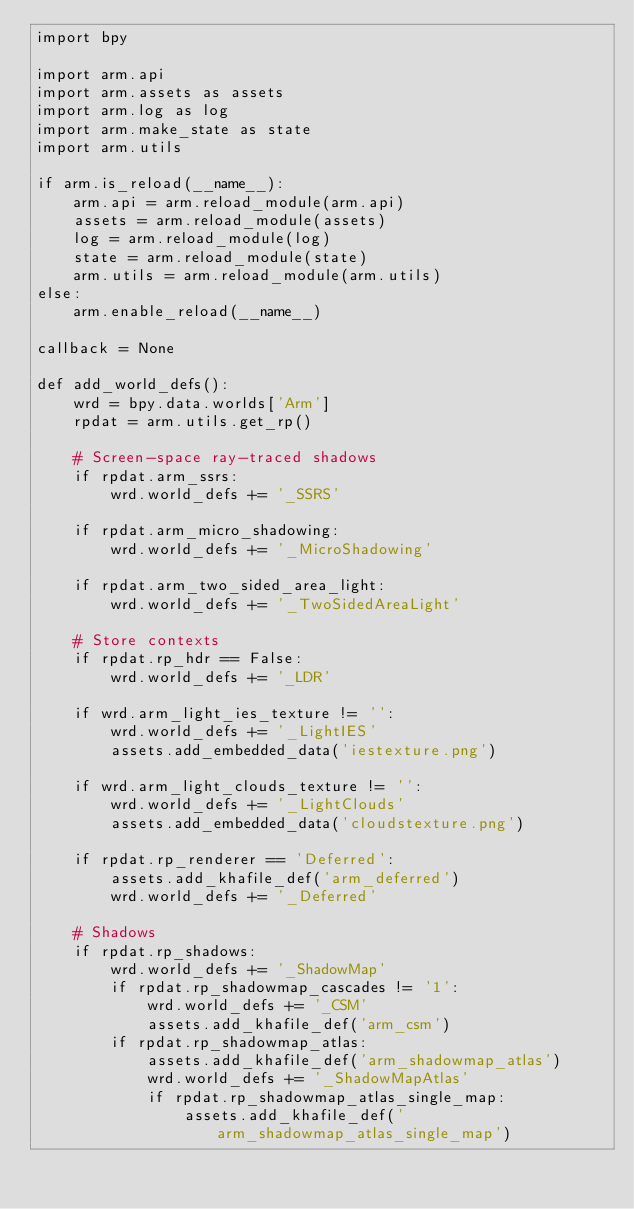<code> <loc_0><loc_0><loc_500><loc_500><_Python_>import bpy

import arm.api
import arm.assets as assets
import arm.log as log
import arm.make_state as state
import arm.utils

if arm.is_reload(__name__):
    arm.api = arm.reload_module(arm.api)
    assets = arm.reload_module(assets)
    log = arm.reload_module(log)
    state = arm.reload_module(state)
    arm.utils = arm.reload_module(arm.utils)
else:
    arm.enable_reload(__name__)

callback = None

def add_world_defs():
    wrd = bpy.data.worlds['Arm']
    rpdat = arm.utils.get_rp()

    # Screen-space ray-traced shadows
    if rpdat.arm_ssrs:
        wrd.world_defs += '_SSRS'

    if rpdat.arm_micro_shadowing:
        wrd.world_defs += '_MicroShadowing'

    if rpdat.arm_two_sided_area_light:
        wrd.world_defs += '_TwoSidedAreaLight'

    # Store contexts
    if rpdat.rp_hdr == False:
        wrd.world_defs += '_LDR'

    if wrd.arm_light_ies_texture != '':
        wrd.world_defs += '_LightIES'
        assets.add_embedded_data('iestexture.png')

    if wrd.arm_light_clouds_texture != '':
        wrd.world_defs += '_LightClouds'
        assets.add_embedded_data('cloudstexture.png')

    if rpdat.rp_renderer == 'Deferred':
        assets.add_khafile_def('arm_deferred')
        wrd.world_defs += '_Deferred'

    # Shadows
    if rpdat.rp_shadows:
        wrd.world_defs += '_ShadowMap'
        if rpdat.rp_shadowmap_cascades != '1':
            wrd.world_defs += '_CSM'
            assets.add_khafile_def('arm_csm')
        if rpdat.rp_shadowmap_atlas:
            assets.add_khafile_def('arm_shadowmap_atlas')
            wrd.world_defs += '_ShadowMapAtlas'
            if rpdat.rp_shadowmap_atlas_single_map:
                assets.add_khafile_def('arm_shadowmap_atlas_single_map')</code> 